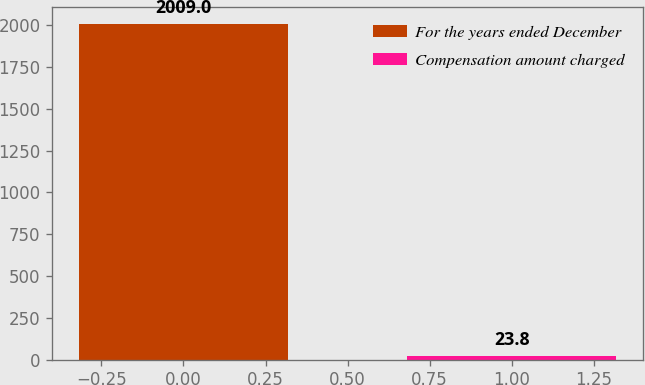<chart> <loc_0><loc_0><loc_500><loc_500><bar_chart><fcel>For the years ended December<fcel>Compensation amount charged<nl><fcel>2009<fcel>23.8<nl></chart> 